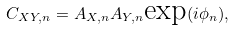<formula> <loc_0><loc_0><loc_500><loc_500>C _ { X Y , n } = A _ { X , n } A _ { Y , n } \text {exp} ( i \phi _ { n } ) ,</formula> 